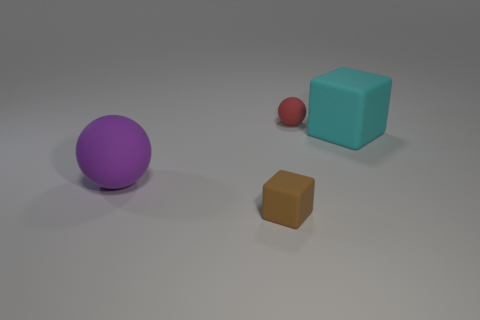Add 1 tiny purple objects. How many objects exist? 5 Add 4 big cyan objects. How many big cyan objects are left? 5 Add 4 purple objects. How many purple objects exist? 5 Subtract 0 brown spheres. How many objects are left? 4 Subtract all small red rubber objects. Subtract all large matte cubes. How many objects are left? 2 